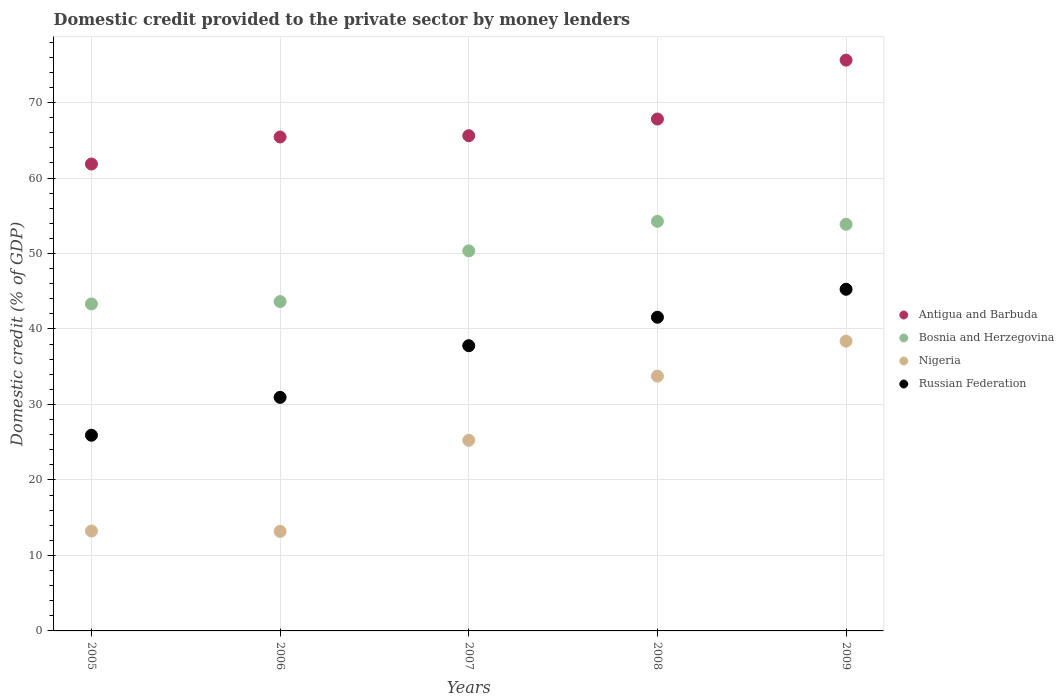What is the domestic credit provided to the private sector by money lenders in Nigeria in 2009?
Your answer should be compact. 38.39. Across all years, what is the maximum domestic credit provided to the private sector by money lenders in Bosnia and Herzegovina?
Your response must be concise. 54.26. Across all years, what is the minimum domestic credit provided to the private sector by money lenders in Russian Federation?
Ensure brevity in your answer.  25.92. In which year was the domestic credit provided to the private sector by money lenders in Nigeria minimum?
Your answer should be very brief. 2006. What is the total domestic credit provided to the private sector by money lenders in Bosnia and Herzegovina in the graph?
Provide a succinct answer. 245.42. What is the difference between the domestic credit provided to the private sector by money lenders in Bosnia and Herzegovina in 2008 and that in 2009?
Offer a very short reply. 0.39. What is the difference between the domestic credit provided to the private sector by money lenders in Nigeria in 2005 and the domestic credit provided to the private sector by money lenders in Bosnia and Herzegovina in 2007?
Your response must be concise. -37.11. What is the average domestic credit provided to the private sector by money lenders in Russian Federation per year?
Ensure brevity in your answer.  36.29. In the year 2006, what is the difference between the domestic credit provided to the private sector by money lenders in Russian Federation and domestic credit provided to the private sector by money lenders in Antigua and Barbuda?
Offer a very short reply. -34.49. In how many years, is the domestic credit provided to the private sector by money lenders in Nigeria greater than 68 %?
Your answer should be very brief. 0. What is the ratio of the domestic credit provided to the private sector by money lenders in Russian Federation in 2008 to that in 2009?
Offer a very short reply. 0.92. Is the difference between the domestic credit provided to the private sector by money lenders in Russian Federation in 2008 and 2009 greater than the difference between the domestic credit provided to the private sector by money lenders in Antigua and Barbuda in 2008 and 2009?
Give a very brief answer. Yes. What is the difference between the highest and the second highest domestic credit provided to the private sector by money lenders in Bosnia and Herzegovina?
Give a very brief answer. 0.39. What is the difference between the highest and the lowest domestic credit provided to the private sector by money lenders in Bosnia and Herzegovina?
Keep it short and to the point. 10.94. In how many years, is the domestic credit provided to the private sector by money lenders in Antigua and Barbuda greater than the average domestic credit provided to the private sector by money lenders in Antigua and Barbuda taken over all years?
Ensure brevity in your answer.  2. Is the sum of the domestic credit provided to the private sector by money lenders in Antigua and Barbuda in 2006 and 2009 greater than the maximum domestic credit provided to the private sector by money lenders in Russian Federation across all years?
Your answer should be compact. Yes. Is it the case that in every year, the sum of the domestic credit provided to the private sector by money lenders in Bosnia and Herzegovina and domestic credit provided to the private sector by money lenders in Antigua and Barbuda  is greater than the domestic credit provided to the private sector by money lenders in Nigeria?
Your response must be concise. Yes. Does the domestic credit provided to the private sector by money lenders in Bosnia and Herzegovina monotonically increase over the years?
Your answer should be compact. No. Are the values on the major ticks of Y-axis written in scientific E-notation?
Your answer should be very brief. No. Does the graph contain grids?
Your response must be concise. Yes. Where does the legend appear in the graph?
Provide a succinct answer. Center right. How many legend labels are there?
Provide a short and direct response. 4. How are the legend labels stacked?
Provide a succinct answer. Vertical. What is the title of the graph?
Offer a terse response. Domestic credit provided to the private sector by money lenders. What is the label or title of the X-axis?
Your answer should be very brief. Years. What is the label or title of the Y-axis?
Your answer should be compact. Domestic credit (% of GDP). What is the Domestic credit (% of GDP) in Antigua and Barbuda in 2005?
Offer a very short reply. 61.85. What is the Domestic credit (% of GDP) of Bosnia and Herzegovina in 2005?
Your answer should be very brief. 43.31. What is the Domestic credit (% of GDP) of Nigeria in 2005?
Ensure brevity in your answer.  13.24. What is the Domestic credit (% of GDP) in Russian Federation in 2005?
Your answer should be compact. 25.92. What is the Domestic credit (% of GDP) of Antigua and Barbuda in 2006?
Offer a terse response. 65.43. What is the Domestic credit (% of GDP) in Bosnia and Herzegovina in 2006?
Give a very brief answer. 43.63. What is the Domestic credit (% of GDP) of Nigeria in 2006?
Make the answer very short. 13.18. What is the Domestic credit (% of GDP) of Russian Federation in 2006?
Provide a short and direct response. 30.94. What is the Domestic credit (% of GDP) in Antigua and Barbuda in 2007?
Your answer should be compact. 65.61. What is the Domestic credit (% of GDP) in Bosnia and Herzegovina in 2007?
Give a very brief answer. 50.35. What is the Domestic credit (% of GDP) of Nigeria in 2007?
Offer a terse response. 25.25. What is the Domestic credit (% of GDP) of Russian Federation in 2007?
Your response must be concise. 37.78. What is the Domestic credit (% of GDP) in Antigua and Barbuda in 2008?
Ensure brevity in your answer.  67.81. What is the Domestic credit (% of GDP) in Bosnia and Herzegovina in 2008?
Give a very brief answer. 54.26. What is the Domestic credit (% of GDP) of Nigeria in 2008?
Make the answer very short. 33.75. What is the Domestic credit (% of GDP) in Russian Federation in 2008?
Ensure brevity in your answer.  41.55. What is the Domestic credit (% of GDP) of Antigua and Barbuda in 2009?
Offer a terse response. 75.61. What is the Domestic credit (% of GDP) in Bosnia and Herzegovina in 2009?
Provide a succinct answer. 53.87. What is the Domestic credit (% of GDP) of Nigeria in 2009?
Your answer should be compact. 38.39. What is the Domestic credit (% of GDP) of Russian Federation in 2009?
Provide a short and direct response. 45.26. Across all years, what is the maximum Domestic credit (% of GDP) in Antigua and Barbuda?
Keep it short and to the point. 75.61. Across all years, what is the maximum Domestic credit (% of GDP) of Bosnia and Herzegovina?
Your answer should be compact. 54.26. Across all years, what is the maximum Domestic credit (% of GDP) in Nigeria?
Ensure brevity in your answer.  38.39. Across all years, what is the maximum Domestic credit (% of GDP) in Russian Federation?
Give a very brief answer. 45.26. Across all years, what is the minimum Domestic credit (% of GDP) in Antigua and Barbuda?
Provide a short and direct response. 61.85. Across all years, what is the minimum Domestic credit (% of GDP) in Bosnia and Herzegovina?
Give a very brief answer. 43.31. Across all years, what is the minimum Domestic credit (% of GDP) of Nigeria?
Your answer should be compact. 13.18. Across all years, what is the minimum Domestic credit (% of GDP) of Russian Federation?
Give a very brief answer. 25.92. What is the total Domestic credit (% of GDP) of Antigua and Barbuda in the graph?
Give a very brief answer. 336.32. What is the total Domestic credit (% of GDP) in Bosnia and Herzegovina in the graph?
Provide a succinct answer. 245.42. What is the total Domestic credit (% of GDP) of Nigeria in the graph?
Make the answer very short. 123.81. What is the total Domestic credit (% of GDP) in Russian Federation in the graph?
Your answer should be very brief. 181.46. What is the difference between the Domestic credit (% of GDP) of Antigua and Barbuda in 2005 and that in 2006?
Your response must be concise. -3.58. What is the difference between the Domestic credit (% of GDP) in Bosnia and Herzegovina in 2005 and that in 2006?
Make the answer very short. -0.31. What is the difference between the Domestic credit (% of GDP) of Nigeria in 2005 and that in 2006?
Ensure brevity in your answer.  0.05. What is the difference between the Domestic credit (% of GDP) of Russian Federation in 2005 and that in 2006?
Make the answer very short. -5.02. What is the difference between the Domestic credit (% of GDP) of Antigua and Barbuda in 2005 and that in 2007?
Make the answer very short. -3.75. What is the difference between the Domestic credit (% of GDP) of Bosnia and Herzegovina in 2005 and that in 2007?
Make the answer very short. -7.03. What is the difference between the Domestic credit (% of GDP) in Nigeria in 2005 and that in 2007?
Provide a short and direct response. -12.01. What is the difference between the Domestic credit (% of GDP) in Russian Federation in 2005 and that in 2007?
Offer a very short reply. -11.86. What is the difference between the Domestic credit (% of GDP) of Antigua and Barbuda in 2005 and that in 2008?
Ensure brevity in your answer.  -5.96. What is the difference between the Domestic credit (% of GDP) of Bosnia and Herzegovina in 2005 and that in 2008?
Your response must be concise. -10.94. What is the difference between the Domestic credit (% of GDP) of Nigeria in 2005 and that in 2008?
Make the answer very short. -20.52. What is the difference between the Domestic credit (% of GDP) of Russian Federation in 2005 and that in 2008?
Offer a terse response. -15.63. What is the difference between the Domestic credit (% of GDP) in Antigua and Barbuda in 2005 and that in 2009?
Keep it short and to the point. -13.76. What is the difference between the Domestic credit (% of GDP) in Bosnia and Herzegovina in 2005 and that in 2009?
Your answer should be very brief. -10.55. What is the difference between the Domestic credit (% of GDP) of Nigeria in 2005 and that in 2009?
Give a very brief answer. -25.15. What is the difference between the Domestic credit (% of GDP) in Russian Federation in 2005 and that in 2009?
Ensure brevity in your answer.  -19.34. What is the difference between the Domestic credit (% of GDP) in Antigua and Barbuda in 2006 and that in 2007?
Provide a succinct answer. -0.17. What is the difference between the Domestic credit (% of GDP) of Bosnia and Herzegovina in 2006 and that in 2007?
Make the answer very short. -6.72. What is the difference between the Domestic credit (% of GDP) of Nigeria in 2006 and that in 2007?
Provide a short and direct response. -12.07. What is the difference between the Domestic credit (% of GDP) in Russian Federation in 2006 and that in 2007?
Your response must be concise. -6.84. What is the difference between the Domestic credit (% of GDP) in Antigua and Barbuda in 2006 and that in 2008?
Ensure brevity in your answer.  -2.38. What is the difference between the Domestic credit (% of GDP) in Bosnia and Herzegovina in 2006 and that in 2008?
Keep it short and to the point. -10.63. What is the difference between the Domestic credit (% of GDP) in Nigeria in 2006 and that in 2008?
Make the answer very short. -20.57. What is the difference between the Domestic credit (% of GDP) of Russian Federation in 2006 and that in 2008?
Your answer should be very brief. -10.61. What is the difference between the Domestic credit (% of GDP) of Antigua and Barbuda in 2006 and that in 2009?
Make the answer very short. -10.18. What is the difference between the Domestic credit (% of GDP) of Bosnia and Herzegovina in 2006 and that in 2009?
Provide a short and direct response. -10.24. What is the difference between the Domestic credit (% of GDP) of Nigeria in 2006 and that in 2009?
Offer a very short reply. -25.2. What is the difference between the Domestic credit (% of GDP) in Russian Federation in 2006 and that in 2009?
Provide a short and direct response. -14.32. What is the difference between the Domestic credit (% of GDP) of Antigua and Barbuda in 2007 and that in 2008?
Ensure brevity in your answer.  -2.2. What is the difference between the Domestic credit (% of GDP) in Bosnia and Herzegovina in 2007 and that in 2008?
Your response must be concise. -3.91. What is the difference between the Domestic credit (% of GDP) in Nigeria in 2007 and that in 2008?
Your answer should be compact. -8.5. What is the difference between the Domestic credit (% of GDP) in Russian Federation in 2007 and that in 2008?
Your response must be concise. -3.77. What is the difference between the Domestic credit (% of GDP) in Antigua and Barbuda in 2007 and that in 2009?
Offer a very short reply. -10.01. What is the difference between the Domestic credit (% of GDP) in Bosnia and Herzegovina in 2007 and that in 2009?
Offer a terse response. -3.52. What is the difference between the Domestic credit (% of GDP) in Nigeria in 2007 and that in 2009?
Provide a succinct answer. -13.14. What is the difference between the Domestic credit (% of GDP) in Russian Federation in 2007 and that in 2009?
Give a very brief answer. -7.48. What is the difference between the Domestic credit (% of GDP) of Antigua and Barbuda in 2008 and that in 2009?
Your response must be concise. -7.8. What is the difference between the Domestic credit (% of GDP) in Bosnia and Herzegovina in 2008 and that in 2009?
Make the answer very short. 0.39. What is the difference between the Domestic credit (% of GDP) in Nigeria in 2008 and that in 2009?
Give a very brief answer. -4.64. What is the difference between the Domestic credit (% of GDP) in Russian Federation in 2008 and that in 2009?
Your answer should be compact. -3.71. What is the difference between the Domestic credit (% of GDP) of Antigua and Barbuda in 2005 and the Domestic credit (% of GDP) of Bosnia and Herzegovina in 2006?
Your answer should be compact. 18.22. What is the difference between the Domestic credit (% of GDP) in Antigua and Barbuda in 2005 and the Domestic credit (% of GDP) in Nigeria in 2006?
Keep it short and to the point. 48.67. What is the difference between the Domestic credit (% of GDP) of Antigua and Barbuda in 2005 and the Domestic credit (% of GDP) of Russian Federation in 2006?
Your response must be concise. 30.91. What is the difference between the Domestic credit (% of GDP) in Bosnia and Herzegovina in 2005 and the Domestic credit (% of GDP) in Nigeria in 2006?
Keep it short and to the point. 30.13. What is the difference between the Domestic credit (% of GDP) of Bosnia and Herzegovina in 2005 and the Domestic credit (% of GDP) of Russian Federation in 2006?
Your answer should be very brief. 12.37. What is the difference between the Domestic credit (% of GDP) of Nigeria in 2005 and the Domestic credit (% of GDP) of Russian Federation in 2006?
Your response must be concise. -17.71. What is the difference between the Domestic credit (% of GDP) of Antigua and Barbuda in 2005 and the Domestic credit (% of GDP) of Bosnia and Herzegovina in 2007?
Ensure brevity in your answer.  11.51. What is the difference between the Domestic credit (% of GDP) of Antigua and Barbuda in 2005 and the Domestic credit (% of GDP) of Nigeria in 2007?
Give a very brief answer. 36.6. What is the difference between the Domestic credit (% of GDP) of Antigua and Barbuda in 2005 and the Domestic credit (% of GDP) of Russian Federation in 2007?
Ensure brevity in your answer.  24.07. What is the difference between the Domestic credit (% of GDP) of Bosnia and Herzegovina in 2005 and the Domestic credit (% of GDP) of Nigeria in 2007?
Ensure brevity in your answer.  18.07. What is the difference between the Domestic credit (% of GDP) of Bosnia and Herzegovina in 2005 and the Domestic credit (% of GDP) of Russian Federation in 2007?
Provide a succinct answer. 5.53. What is the difference between the Domestic credit (% of GDP) of Nigeria in 2005 and the Domestic credit (% of GDP) of Russian Federation in 2007?
Offer a terse response. -24.55. What is the difference between the Domestic credit (% of GDP) in Antigua and Barbuda in 2005 and the Domestic credit (% of GDP) in Bosnia and Herzegovina in 2008?
Offer a very short reply. 7.59. What is the difference between the Domestic credit (% of GDP) of Antigua and Barbuda in 2005 and the Domestic credit (% of GDP) of Nigeria in 2008?
Ensure brevity in your answer.  28.1. What is the difference between the Domestic credit (% of GDP) of Antigua and Barbuda in 2005 and the Domestic credit (% of GDP) of Russian Federation in 2008?
Provide a short and direct response. 20.3. What is the difference between the Domestic credit (% of GDP) in Bosnia and Herzegovina in 2005 and the Domestic credit (% of GDP) in Nigeria in 2008?
Give a very brief answer. 9.56. What is the difference between the Domestic credit (% of GDP) of Bosnia and Herzegovina in 2005 and the Domestic credit (% of GDP) of Russian Federation in 2008?
Make the answer very short. 1.76. What is the difference between the Domestic credit (% of GDP) in Nigeria in 2005 and the Domestic credit (% of GDP) in Russian Federation in 2008?
Ensure brevity in your answer.  -28.32. What is the difference between the Domestic credit (% of GDP) in Antigua and Barbuda in 2005 and the Domestic credit (% of GDP) in Bosnia and Herzegovina in 2009?
Make the answer very short. 7.99. What is the difference between the Domestic credit (% of GDP) of Antigua and Barbuda in 2005 and the Domestic credit (% of GDP) of Nigeria in 2009?
Provide a succinct answer. 23.47. What is the difference between the Domestic credit (% of GDP) of Antigua and Barbuda in 2005 and the Domestic credit (% of GDP) of Russian Federation in 2009?
Provide a short and direct response. 16.59. What is the difference between the Domestic credit (% of GDP) of Bosnia and Herzegovina in 2005 and the Domestic credit (% of GDP) of Nigeria in 2009?
Give a very brief answer. 4.93. What is the difference between the Domestic credit (% of GDP) of Bosnia and Herzegovina in 2005 and the Domestic credit (% of GDP) of Russian Federation in 2009?
Your response must be concise. -1.95. What is the difference between the Domestic credit (% of GDP) in Nigeria in 2005 and the Domestic credit (% of GDP) in Russian Federation in 2009?
Offer a terse response. -32.02. What is the difference between the Domestic credit (% of GDP) in Antigua and Barbuda in 2006 and the Domestic credit (% of GDP) in Bosnia and Herzegovina in 2007?
Provide a short and direct response. 15.09. What is the difference between the Domestic credit (% of GDP) in Antigua and Barbuda in 2006 and the Domestic credit (% of GDP) in Nigeria in 2007?
Your response must be concise. 40.18. What is the difference between the Domestic credit (% of GDP) of Antigua and Barbuda in 2006 and the Domestic credit (% of GDP) of Russian Federation in 2007?
Provide a short and direct response. 27.65. What is the difference between the Domestic credit (% of GDP) of Bosnia and Herzegovina in 2006 and the Domestic credit (% of GDP) of Nigeria in 2007?
Offer a very short reply. 18.38. What is the difference between the Domestic credit (% of GDP) of Bosnia and Herzegovina in 2006 and the Domestic credit (% of GDP) of Russian Federation in 2007?
Your answer should be compact. 5.85. What is the difference between the Domestic credit (% of GDP) in Nigeria in 2006 and the Domestic credit (% of GDP) in Russian Federation in 2007?
Make the answer very short. -24.6. What is the difference between the Domestic credit (% of GDP) in Antigua and Barbuda in 2006 and the Domestic credit (% of GDP) in Bosnia and Herzegovina in 2008?
Provide a short and direct response. 11.17. What is the difference between the Domestic credit (% of GDP) in Antigua and Barbuda in 2006 and the Domestic credit (% of GDP) in Nigeria in 2008?
Your answer should be very brief. 31.68. What is the difference between the Domestic credit (% of GDP) of Antigua and Barbuda in 2006 and the Domestic credit (% of GDP) of Russian Federation in 2008?
Offer a very short reply. 23.88. What is the difference between the Domestic credit (% of GDP) of Bosnia and Herzegovina in 2006 and the Domestic credit (% of GDP) of Nigeria in 2008?
Provide a short and direct response. 9.88. What is the difference between the Domestic credit (% of GDP) in Bosnia and Herzegovina in 2006 and the Domestic credit (% of GDP) in Russian Federation in 2008?
Your answer should be compact. 2.08. What is the difference between the Domestic credit (% of GDP) of Nigeria in 2006 and the Domestic credit (% of GDP) of Russian Federation in 2008?
Your response must be concise. -28.37. What is the difference between the Domestic credit (% of GDP) in Antigua and Barbuda in 2006 and the Domestic credit (% of GDP) in Bosnia and Herzegovina in 2009?
Your answer should be compact. 11.57. What is the difference between the Domestic credit (% of GDP) of Antigua and Barbuda in 2006 and the Domestic credit (% of GDP) of Nigeria in 2009?
Provide a succinct answer. 27.05. What is the difference between the Domestic credit (% of GDP) in Antigua and Barbuda in 2006 and the Domestic credit (% of GDP) in Russian Federation in 2009?
Your answer should be compact. 20.17. What is the difference between the Domestic credit (% of GDP) in Bosnia and Herzegovina in 2006 and the Domestic credit (% of GDP) in Nigeria in 2009?
Ensure brevity in your answer.  5.24. What is the difference between the Domestic credit (% of GDP) in Bosnia and Herzegovina in 2006 and the Domestic credit (% of GDP) in Russian Federation in 2009?
Offer a very short reply. -1.63. What is the difference between the Domestic credit (% of GDP) in Nigeria in 2006 and the Domestic credit (% of GDP) in Russian Federation in 2009?
Ensure brevity in your answer.  -32.08. What is the difference between the Domestic credit (% of GDP) of Antigua and Barbuda in 2007 and the Domestic credit (% of GDP) of Bosnia and Herzegovina in 2008?
Offer a very short reply. 11.35. What is the difference between the Domestic credit (% of GDP) of Antigua and Barbuda in 2007 and the Domestic credit (% of GDP) of Nigeria in 2008?
Your answer should be very brief. 31.85. What is the difference between the Domestic credit (% of GDP) in Antigua and Barbuda in 2007 and the Domestic credit (% of GDP) in Russian Federation in 2008?
Make the answer very short. 24.05. What is the difference between the Domestic credit (% of GDP) of Bosnia and Herzegovina in 2007 and the Domestic credit (% of GDP) of Nigeria in 2008?
Give a very brief answer. 16.6. What is the difference between the Domestic credit (% of GDP) of Bosnia and Herzegovina in 2007 and the Domestic credit (% of GDP) of Russian Federation in 2008?
Make the answer very short. 8.79. What is the difference between the Domestic credit (% of GDP) in Nigeria in 2007 and the Domestic credit (% of GDP) in Russian Federation in 2008?
Offer a terse response. -16.31. What is the difference between the Domestic credit (% of GDP) in Antigua and Barbuda in 2007 and the Domestic credit (% of GDP) in Bosnia and Herzegovina in 2009?
Provide a short and direct response. 11.74. What is the difference between the Domestic credit (% of GDP) of Antigua and Barbuda in 2007 and the Domestic credit (% of GDP) of Nigeria in 2009?
Provide a succinct answer. 27.22. What is the difference between the Domestic credit (% of GDP) of Antigua and Barbuda in 2007 and the Domestic credit (% of GDP) of Russian Federation in 2009?
Offer a terse response. 20.35. What is the difference between the Domestic credit (% of GDP) in Bosnia and Herzegovina in 2007 and the Domestic credit (% of GDP) in Nigeria in 2009?
Make the answer very short. 11.96. What is the difference between the Domestic credit (% of GDP) of Bosnia and Herzegovina in 2007 and the Domestic credit (% of GDP) of Russian Federation in 2009?
Your answer should be very brief. 5.09. What is the difference between the Domestic credit (% of GDP) in Nigeria in 2007 and the Domestic credit (% of GDP) in Russian Federation in 2009?
Provide a short and direct response. -20.01. What is the difference between the Domestic credit (% of GDP) in Antigua and Barbuda in 2008 and the Domestic credit (% of GDP) in Bosnia and Herzegovina in 2009?
Your answer should be compact. 13.94. What is the difference between the Domestic credit (% of GDP) of Antigua and Barbuda in 2008 and the Domestic credit (% of GDP) of Nigeria in 2009?
Your response must be concise. 29.42. What is the difference between the Domestic credit (% of GDP) of Antigua and Barbuda in 2008 and the Domestic credit (% of GDP) of Russian Federation in 2009?
Give a very brief answer. 22.55. What is the difference between the Domestic credit (% of GDP) in Bosnia and Herzegovina in 2008 and the Domestic credit (% of GDP) in Nigeria in 2009?
Your answer should be compact. 15.87. What is the difference between the Domestic credit (% of GDP) of Bosnia and Herzegovina in 2008 and the Domestic credit (% of GDP) of Russian Federation in 2009?
Your answer should be compact. 9. What is the difference between the Domestic credit (% of GDP) of Nigeria in 2008 and the Domestic credit (% of GDP) of Russian Federation in 2009?
Your answer should be compact. -11.51. What is the average Domestic credit (% of GDP) of Antigua and Barbuda per year?
Give a very brief answer. 67.26. What is the average Domestic credit (% of GDP) of Bosnia and Herzegovina per year?
Provide a short and direct response. 49.08. What is the average Domestic credit (% of GDP) in Nigeria per year?
Provide a short and direct response. 24.76. What is the average Domestic credit (% of GDP) in Russian Federation per year?
Give a very brief answer. 36.29. In the year 2005, what is the difference between the Domestic credit (% of GDP) in Antigua and Barbuda and Domestic credit (% of GDP) in Bosnia and Herzegovina?
Keep it short and to the point. 18.54. In the year 2005, what is the difference between the Domestic credit (% of GDP) of Antigua and Barbuda and Domestic credit (% of GDP) of Nigeria?
Provide a short and direct response. 48.62. In the year 2005, what is the difference between the Domestic credit (% of GDP) in Antigua and Barbuda and Domestic credit (% of GDP) in Russian Federation?
Provide a succinct answer. 35.93. In the year 2005, what is the difference between the Domestic credit (% of GDP) in Bosnia and Herzegovina and Domestic credit (% of GDP) in Nigeria?
Offer a terse response. 30.08. In the year 2005, what is the difference between the Domestic credit (% of GDP) in Bosnia and Herzegovina and Domestic credit (% of GDP) in Russian Federation?
Provide a succinct answer. 17.39. In the year 2005, what is the difference between the Domestic credit (% of GDP) in Nigeria and Domestic credit (% of GDP) in Russian Federation?
Provide a short and direct response. -12.69. In the year 2006, what is the difference between the Domestic credit (% of GDP) of Antigua and Barbuda and Domestic credit (% of GDP) of Bosnia and Herzegovina?
Provide a succinct answer. 21.8. In the year 2006, what is the difference between the Domestic credit (% of GDP) of Antigua and Barbuda and Domestic credit (% of GDP) of Nigeria?
Your answer should be compact. 52.25. In the year 2006, what is the difference between the Domestic credit (% of GDP) in Antigua and Barbuda and Domestic credit (% of GDP) in Russian Federation?
Provide a succinct answer. 34.49. In the year 2006, what is the difference between the Domestic credit (% of GDP) of Bosnia and Herzegovina and Domestic credit (% of GDP) of Nigeria?
Your answer should be very brief. 30.45. In the year 2006, what is the difference between the Domestic credit (% of GDP) in Bosnia and Herzegovina and Domestic credit (% of GDP) in Russian Federation?
Make the answer very short. 12.69. In the year 2006, what is the difference between the Domestic credit (% of GDP) in Nigeria and Domestic credit (% of GDP) in Russian Federation?
Give a very brief answer. -17.76. In the year 2007, what is the difference between the Domestic credit (% of GDP) of Antigua and Barbuda and Domestic credit (% of GDP) of Bosnia and Herzegovina?
Make the answer very short. 15.26. In the year 2007, what is the difference between the Domestic credit (% of GDP) in Antigua and Barbuda and Domestic credit (% of GDP) in Nigeria?
Keep it short and to the point. 40.36. In the year 2007, what is the difference between the Domestic credit (% of GDP) of Antigua and Barbuda and Domestic credit (% of GDP) of Russian Federation?
Keep it short and to the point. 27.82. In the year 2007, what is the difference between the Domestic credit (% of GDP) in Bosnia and Herzegovina and Domestic credit (% of GDP) in Nigeria?
Your answer should be very brief. 25.1. In the year 2007, what is the difference between the Domestic credit (% of GDP) in Bosnia and Herzegovina and Domestic credit (% of GDP) in Russian Federation?
Keep it short and to the point. 12.56. In the year 2007, what is the difference between the Domestic credit (% of GDP) in Nigeria and Domestic credit (% of GDP) in Russian Federation?
Provide a short and direct response. -12.53. In the year 2008, what is the difference between the Domestic credit (% of GDP) of Antigua and Barbuda and Domestic credit (% of GDP) of Bosnia and Herzegovina?
Provide a succinct answer. 13.55. In the year 2008, what is the difference between the Domestic credit (% of GDP) of Antigua and Barbuda and Domestic credit (% of GDP) of Nigeria?
Provide a short and direct response. 34.06. In the year 2008, what is the difference between the Domestic credit (% of GDP) of Antigua and Barbuda and Domestic credit (% of GDP) of Russian Federation?
Offer a terse response. 26.26. In the year 2008, what is the difference between the Domestic credit (% of GDP) in Bosnia and Herzegovina and Domestic credit (% of GDP) in Nigeria?
Give a very brief answer. 20.51. In the year 2008, what is the difference between the Domestic credit (% of GDP) of Bosnia and Herzegovina and Domestic credit (% of GDP) of Russian Federation?
Offer a very short reply. 12.7. In the year 2008, what is the difference between the Domestic credit (% of GDP) of Nigeria and Domestic credit (% of GDP) of Russian Federation?
Offer a terse response. -7.8. In the year 2009, what is the difference between the Domestic credit (% of GDP) in Antigua and Barbuda and Domestic credit (% of GDP) in Bosnia and Herzegovina?
Your answer should be very brief. 21.75. In the year 2009, what is the difference between the Domestic credit (% of GDP) of Antigua and Barbuda and Domestic credit (% of GDP) of Nigeria?
Make the answer very short. 37.23. In the year 2009, what is the difference between the Domestic credit (% of GDP) of Antigua and Barbuda and Domestic credit (% of GDP) of Russian Federation?
Give a very brief answer. 30.35. In the year 2009, what is the difference between the Domestic credit (% of GDP) in Bosnia and Herzegovina and Domestic credit (% of GDP) in Nigeria?
Offer a very short reply. 15.48. In the year 2009, what is the difference between the Domestic credit (% of GDP) in Bosnia and Herzegovina and Domestic credit (% of GDP) in Russian Federation?
Your answer should be very brief. 8.61. In the year 2009, what is the difference between the Domestic credit (% of GDP) of Nigeria and Domestic credit (% of GDP) of Russian Federation?
Ensure brevity in your answer.  -6.87. What is the ratio of the Domestic credit (% of GDP) of Antigua and Barbuda in 2005 to that in 2006?
Your answer should be compact. 0.95. What is the ratio of the Domestic credit (% of GDP) in Russian Federation in 2005 to that in 2006?
Provide a succinct answer. 0.84. What is the ratio of the Domestic credit (% of GDP) of Antigua and Barbuda in 2005 to that in 2007?
Offer a very short reply. 0.94. What is the ratio of the Domestic credit (% of GDP) in Bosnia and Herzegovina in 2005 to that in 2007?
Offer a terse response. 0.86. What is the ratio of the Domestic credit (% of GDP) in Nigeria in 2005 to that in 2007?
Keep it short and to the point. 0.52. What is the ratio of the Domestic credit (% of GDP) in Russian Federation in 2005 to that in 2007?
Offer a very short reply. 0.69. What is the ratio of the Domestic credit (% of GDP) of Antigua and Barbuda in 2005 to that in 2008?
Make the answer very short. 0.91. What is the ratio of the Domestic credit (% of GDP) of Bosnia and Herzegovina in 2005 to that in 2008?
Your answer should be compact. 0.8. What is the ratio of the Domestic credit (% of GDP) of Nigeria in 2005 to that in 2008?
Provide a succinct answer. 0.39. What is the ratio of the Domestic credit (% of GDP) in Russian Federation in 2005 to that in 2008?
Provide a short and direct response. 0.62. What is the ratio of the Domestic credit (% of GDP) in Antigua and Barbuda in 2005 to that in 2009?
Your response must be concise. 0.82. What is the ratio of the Domestic credit (% of GDP) of Bosnia and Herzegovina in 2005 to that in 2009?
Ensure brevity in your answer.  0.8. What is the ratio of the Domestic credit (% of GDP) of Nigeria in 2005 to that in 2009?
Your answer should be compact. 0.34. What is the ratio of the Domestic credit (% of GDP) of Russian Federation in 2005 to that in 2009?
Provide a short and direct response. 0.57. What is the ratio of the Domestic credit (% of GDP) of Bosnia and Herzegovina in 2006 to that in 2007?
Offer a very short reply. 0.87. What is the ratio of the Domestic credit (% of GDP) in Nigeria in 2006 to that in 2007?
Your answer should be very brief. 0.52. What is the ratio of the Domestic credit (% of GDP) of Russian Federation in 2006 to that in 2007?
Your answer should be very brief. 0.82. What is the ratio of the Domestic credit (% of GDP) in Antigua and Barbuda in 2006 to that in 2008?
Offer a terse response. 0.96. What is the ratio of the Domestic credit (% of GDP) in Bosnia and Herzegovina in 2006 to that in 2008?
Your response must be concise. 0.8. What is the ratio of the Domestic credit (% of GDP) of Nigeria in 2006 to that in 2008?
Your response must be concise. 0.39. What is the ratio of the Domestic credit (% of GDP) of Russian Federation in 2006 to that in 2008?
Give a very brief answer. 0.74. What is the ratio of the Domestic credit (% of GDP) of Antigua and Barbuda in 2006 to that in 2009?
Keep it short and to the point. 0.87. What is the ratio of the Domestic credit (% of GDP) in Bosnia and Herzegovina in 2006 to that in 2009?
Keep it short and to the point. 0.81. What is the ratio of the Domestic credit (% of GDP) in Nigeria in 2006 to that in 2009?
Your answer should be very brief. 0.34. What is the ratio of the Domestic credit (% of GDP) of Russian Federation in 2006 to that in 2009?
Your answer should be compact. 0.68. What is the ratio of the Domestic credit (% of GDP) of Antigua and Barbuda in 2007 to that in 2008?
Provide a short and direct response. 0.97. What is the ratio of the Domestic credit (% of GDP) in Bosnia and Herzegovina in 2007 to that in 2008?
Provide a short and direct response. 0.93. What is the ratio of the Domestic credit (% of GDP) in Nigeria in 2007 to that in 2008?
Offer a terse response. 0.75. What is the ratio of the Domestic credit (% of GDP) of Russian Federation in 2007 to that in 2008?
Your answer should be compact. 0.91. What is the ratio of the Domestic credit (% of GDP) of Antigua and Barbuda in 2007 to that in 2009?
Ensure brevity in your answer.  0.87. What is the ratio of the Domestic credit (% of GDP) of Bosnia and Herzegovina in 2007 to that in 2009?
Give a very brief answer. 0.93. What is the ratio of the Domestic credit (% of GDP) of Nigeria in 2007 to that in 2009?
Your response must be concise. 0.66. What is the ratio of the Domestic credit (% of GDP) of Russian Federation in 2007 to that in 2009?
Offer a terse response. 0.83. What is the ratio of the Domestic credit (% of GDP) of Antigua and Barbuda in 2008 to that in 2009?
Your answer should be compact. 0.9. What is the ratio of the Domestic credit (% of GDP) of Bosnia and Herzegovina in 2008 to that in 2009?
Give a very brief answer. 1.01. What is the ratio of the Domestic credit (% of GDP) in Nigeria in 2008 to that in 2009?
Keep it short and to the point. 0.88. What is the ratio of the Domestic credit (% of GDP) in Russian Federation in 2008 to that in 2009?
Offer a terse response. 0.92. What is the difference between the highest and the second highest Domestic credit (% of GDP) of Antigua and Barbuda?
Your response must be concise. 7.8. What is the difference between the highest and the second highest Domestic credit (% of GDP) of Bosnia and Herzegovina?
Provide a succinct answer. 0.39. What is the difference between the highest and the second highest Domestic credit (% of GDP) of Nigeria?
Your answer should be very brief. 4.64. What is the difference between the highest and the second highest Domestic credit (% of GDP) in Russian Federation?
Ensure brevity in your answer.  3.71. What is the difference between the highest and the lowest Domestic credit (% of GDP) of Antigua and Barbuda?
Your response must be concise. 13.76. What is the difference between the highest and the lowest Domestic credit (% of GDP) in Bosnia and Herzegovina?
Your response must be concise. 10.94. What is the difference between the highest and the lowest Domestic credit (% of GDP) of Nigeria?
Your answer should be compact. 25.2. What is the difference between the highest and the lowest Domestic credit (% of GDP) of Russian Federation?
Keep it short and to the point. 19.34. 